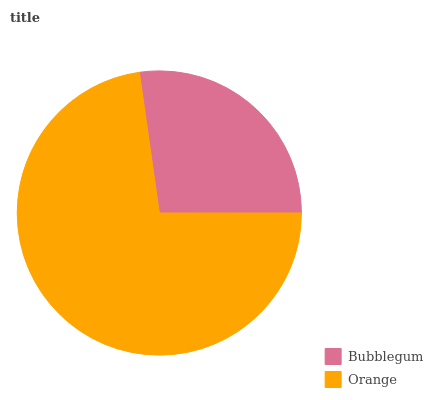Is Bubblegum the minimum?
Answer yes or no. Yes. Is Orange the maximum?
Answer yes or no. Yes. Is Orange the minimum?
Answer yes or no. No. Is Orange greater than Bubblegum?
Answer yes or no. Yes. Is Bubblegum less than Orange?
Answer yes or no. Yes. Is Bubblegum greater than Orange?
Answer yes or no. No. Is Orange less than Bubblegum?
Answer yes or no. No. Is Orange the high median?
Answer yes or no. Yes. Is Bubblegum the low median?
Answer yes or no. Yes. Is Bubblegum the high median?
Answer yes or no. No. Is Orange the low median?
Answer yes or no. No. 